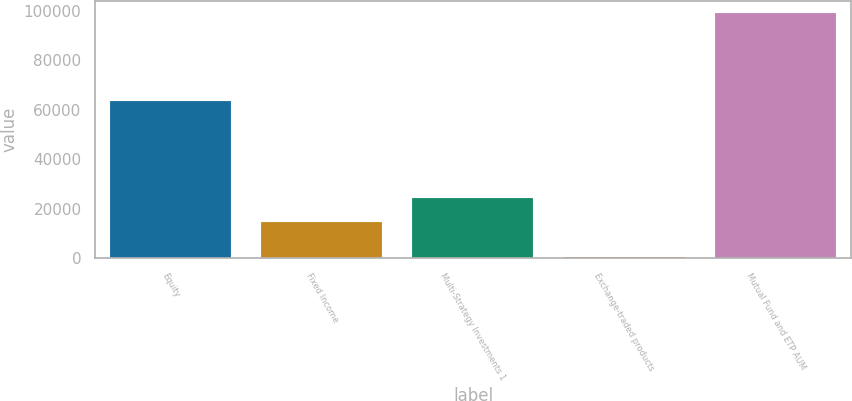Convert chart to OTSL. <chart><loc_0><loc_0><loc_500><loc_500><bar_chart><fcel>Equity<fcel>Fixed Income<fcel>Multi-Strategy Investments 1<fcel>Exchange-traded products<fcel>Mutual Fund and ETP AUM<nl><fcel>63740<fcel>14401<fcel>24262<fcel>480<fcel>99090<nl></chart> 